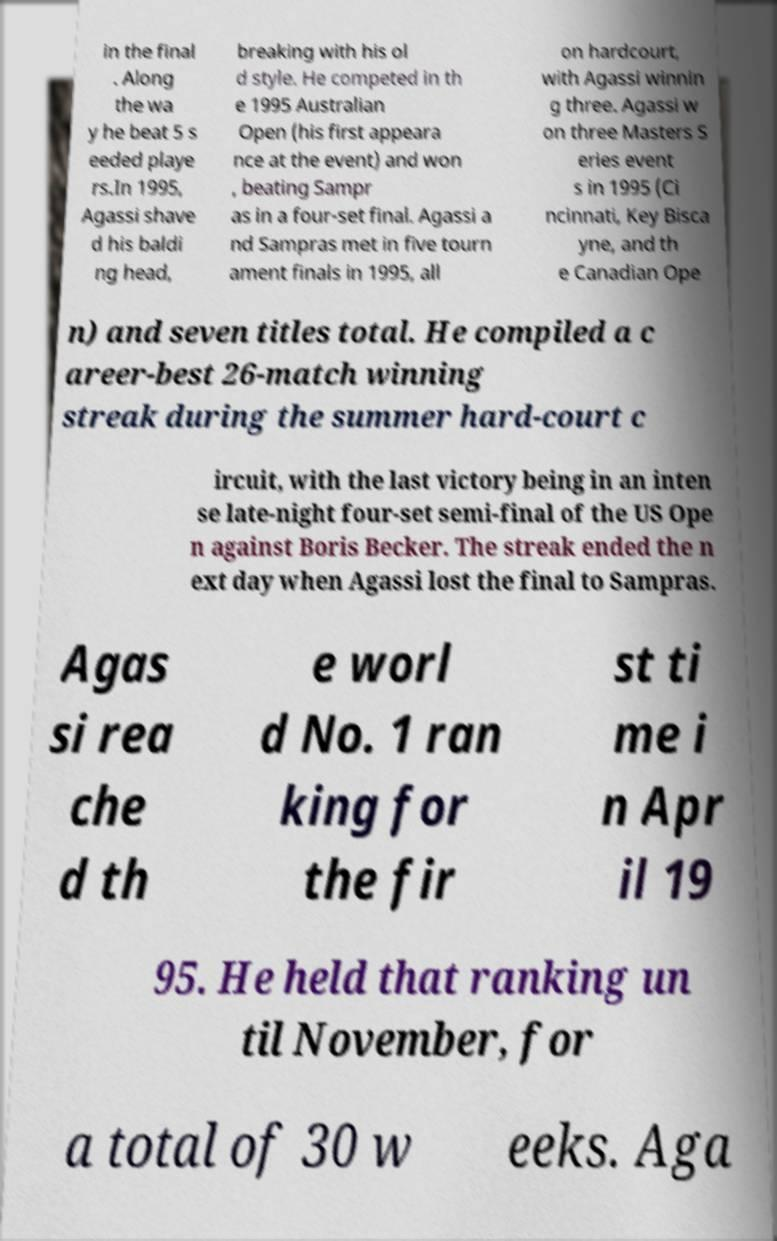There's text embedded in this image that I need extracted. Can you transcribe it verbatim? in the final . Along the wa y he beat 5 s eeded playe rs.In 1995, Agassi shave d his baldi ng head, breaking with his ol d style. He competed in th e 1995 Australian Open (his first appeara nce at the event) and won , beating Sampr as in a four-set final. Agassi a nd Sampras met in five tourn ament finals in 1995, all on hardcourt, with Agassi winnin g three. Agassi w on three Masters S eries event s in 1995 (Ci ncinnati, Key Bisca yne, and th e Canadian Ope n) and seven titles total. He compiled a c areer-best 26-match winning streak during the summer hard-court c ircuit, with the last victory being in an inten se late-night four-set semi-final of the US Ope n against Boris Becker. The streak ended the n ext day when Agassi lost the final to Sampras. Agas si rea che d th e worl d No. 1 ran king for the fir st ti me i n Apr il 19 95. He held that ranking un til November, for a total of 30 w eeks. Aga 